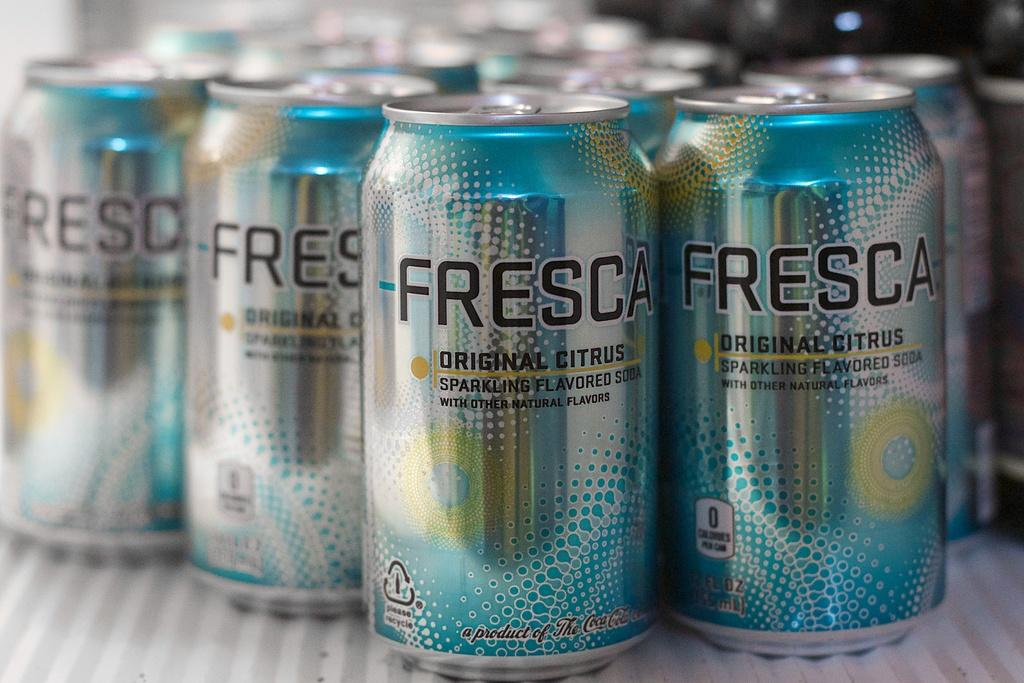<image>
Provide a brief description of the given image. Several cans of Fresca Original Citrus Sparkling Flavored Soda are displayed. 